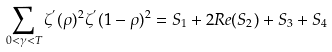<formula> <loc_0><loc_0><loc_500><loc_500>\sum _ { 0 < \gamma < T } \zeta ^ { ^ { \prime } } ( \rho ) ^ { 2 } \zeta ^ { ^ { \prime } } ( 1 - \rho ) ^ { 2 } = S _ { 1 } + 2 R e ( S _ { 2 } ) + S _ { 3 } + S _ { 4 }</formula> 